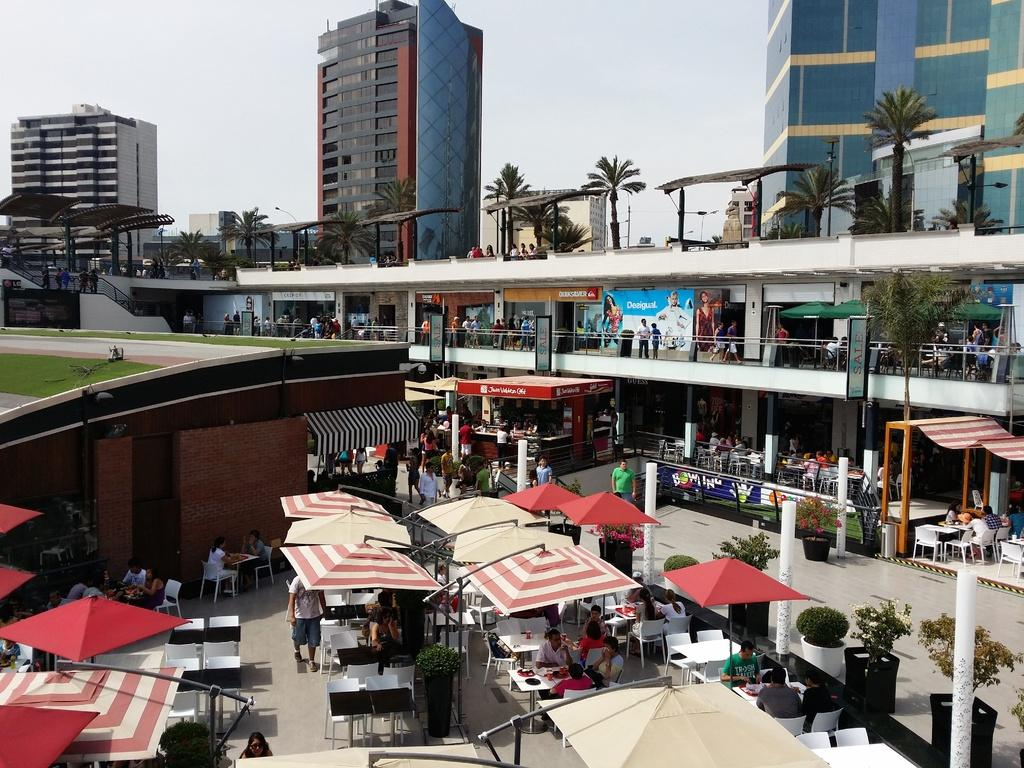What type of structures can be seen in the image? There are buildings in the image. What temporary shelters are present in the image? There are tents in the image. What type of vegetation is visible in the image? There are trees in the image. What are the people in the image doing? There are people standing and sitting on chairs in the image. What is visible in the background of the image? The sky is visible in the image. What type of butter is being used by the dad in the image? There is no dad or butter present in the image. How many cats are visible in the image? There are no cats present in the image. 